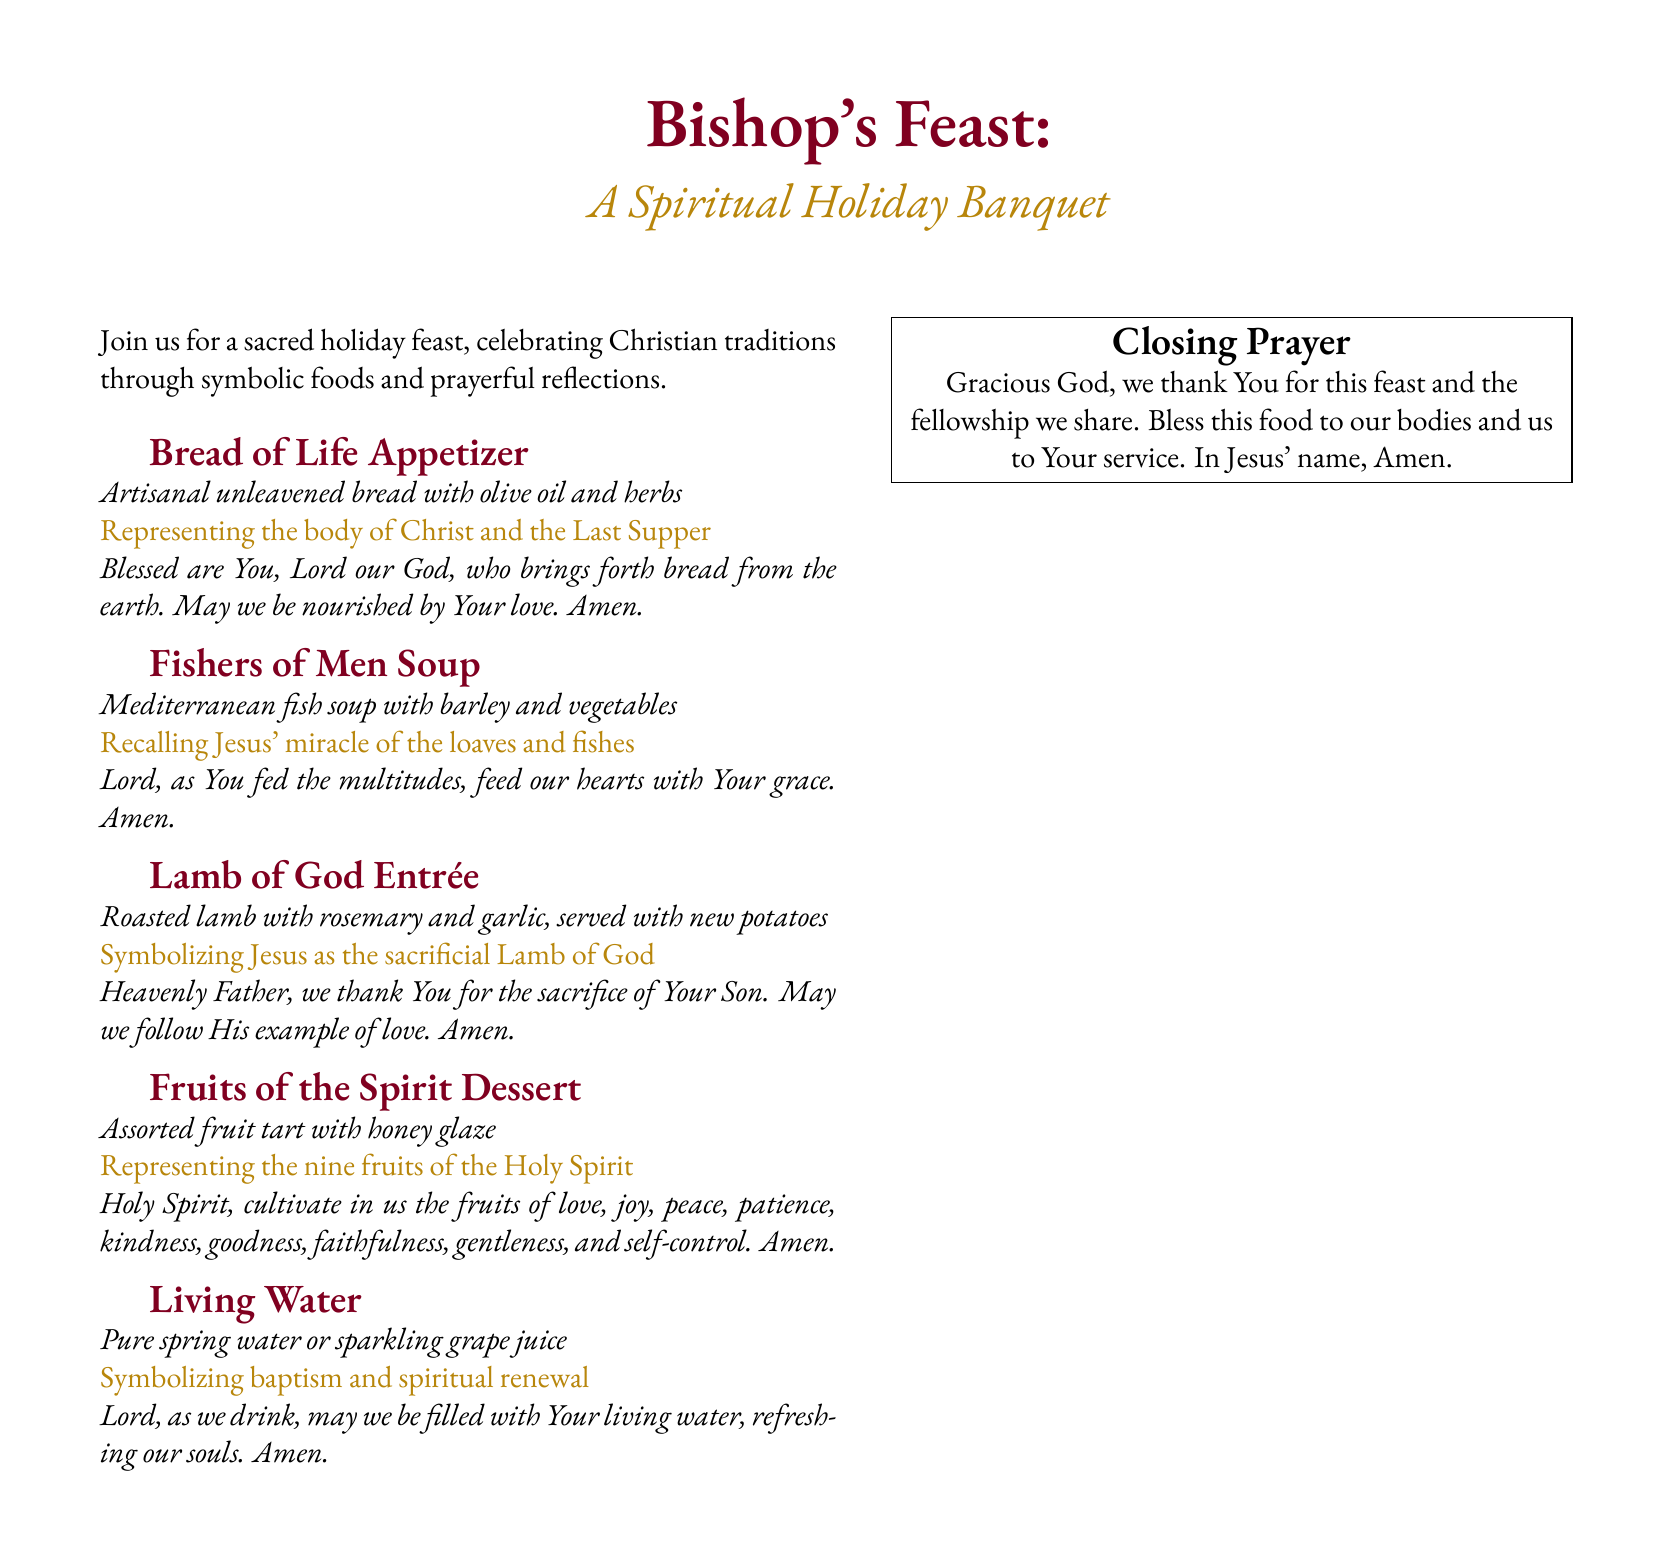What is the title of the menu? The title is prominently displayed at the top of the document and is "Bishop's Feast."
Answer: Bishop's Feast What is the first dish listed on the menu? The first dish mentioned is within the menu section titled "Bread of Life Appetizer."
Answer: Bread of Life Appetizer Which course symbolizes baptism and spiritual renewal? The document identifies "Living Water" as the course that symbolizes baptism and spiritual renewal.
Answer: Living Water What type of bread is served as an appetizer? The document specifies that the appetizer is "Artisanal unleavened bread."
Answer: Artisanal unleavened bread How many fruits are represented in the dessert? The dessert represents the nine fruits of the Holy Spirit as stated in the description.
Answer: Nine What prayer is associated with the Lamb of God Entrée? The specific prayer related to the Lamb of God Entrée is included in the menu under that dish.
Answer: Heavenly Father, we thank You for the sacrifice of Your Son. May we follow His example of love. Amen What color is associated with the title of the menu? The title uses a burgundy color, as described in the styling of the document.
Answer: Burgundy What is the closing prayer focused on? The closing prayer addresses gratitude for the feast and the fellowship shared.
Answer: Gratitude for this feast and the fellowship we share 